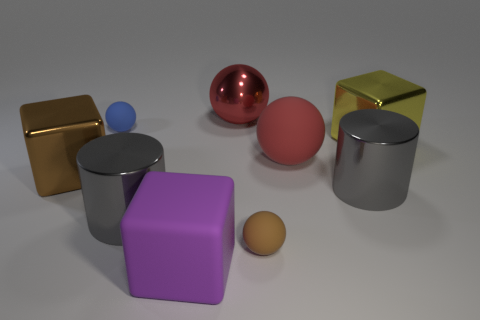Subtract all red spheres. How many were subtracted if there are1red spheres left? 1 Subtract all red shiny balls. How many balls are left? 3 Subtract all brown spheres. How many spheres are left? 3 Subtract 0 cyan balls. How many objects are left? 9 Subtract all spheres. How many objects are left? 5 Subtract 4 spheres. How many spheres are left? 0 Subtract all cyan blocks. Subtract all gray spheres. How many blocks are left? 3 Subtract all red spheres. How many blue cylinders are left? 0 Subtract all shiny cylinders. Subtract all large yellow shiny blocks. How many objects are left? 6 Add 8 yellow objects. How many yellow objects are left? 9 